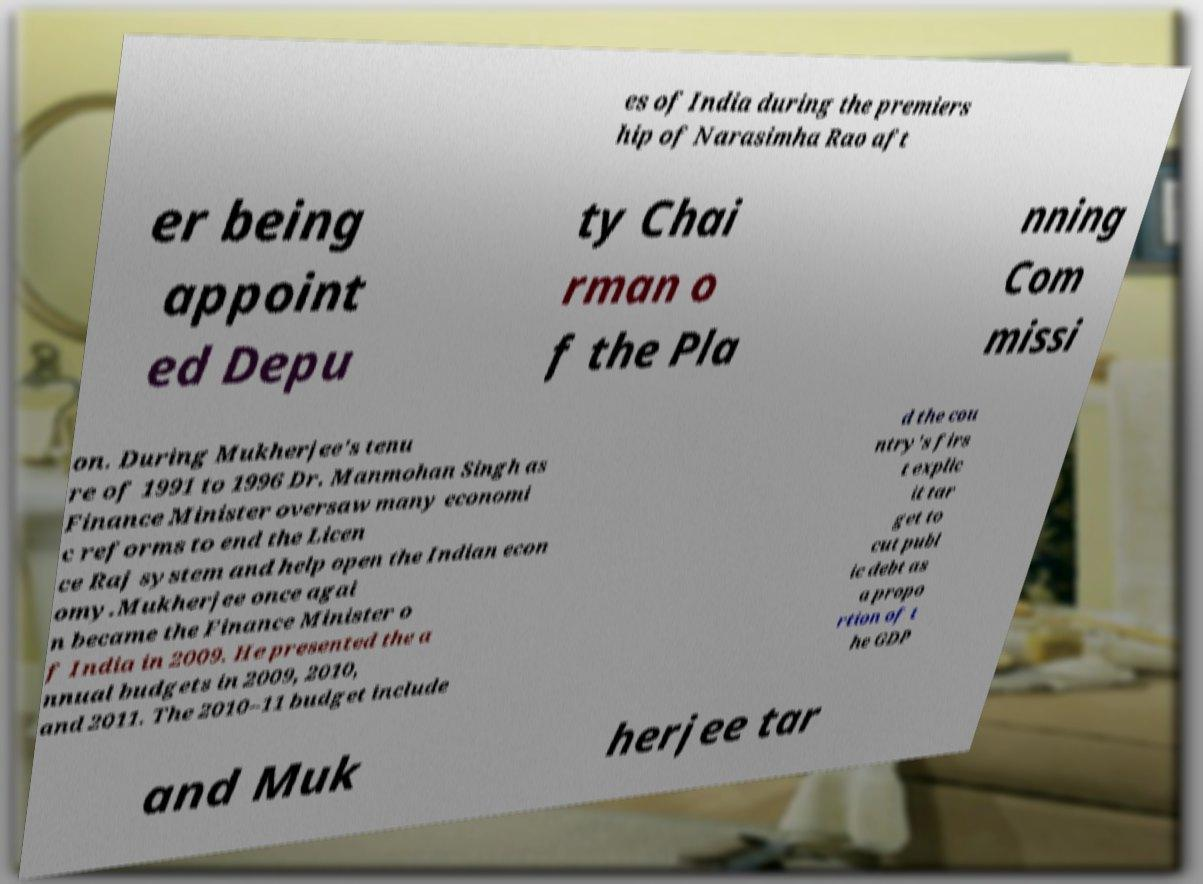For documentation purposes, I need the text within this image transcribed. Could you provide that? es of India during the premiers hip of Narasimha Rao aft er being appoint ed Depu ty Chai rman o f the Pla nning Com missi on. During Mukherjee's tenu re of 1991 to 1996 Dr. Manmohan Singh as Finance Minister oversaw many economi c reforms to end the Licen ce Raj system and help open the Indian econ omy.Mukherjee once agai n became the Finance Minister o f India in 2009. He presented the a nnual budgets in 2009, 2010, and 2011. The 2010–11 budget include d the cou ntry's firs t explic it tar get to cut publ ic debt as a propo rtion of t he GDP and Muk herjee tar 